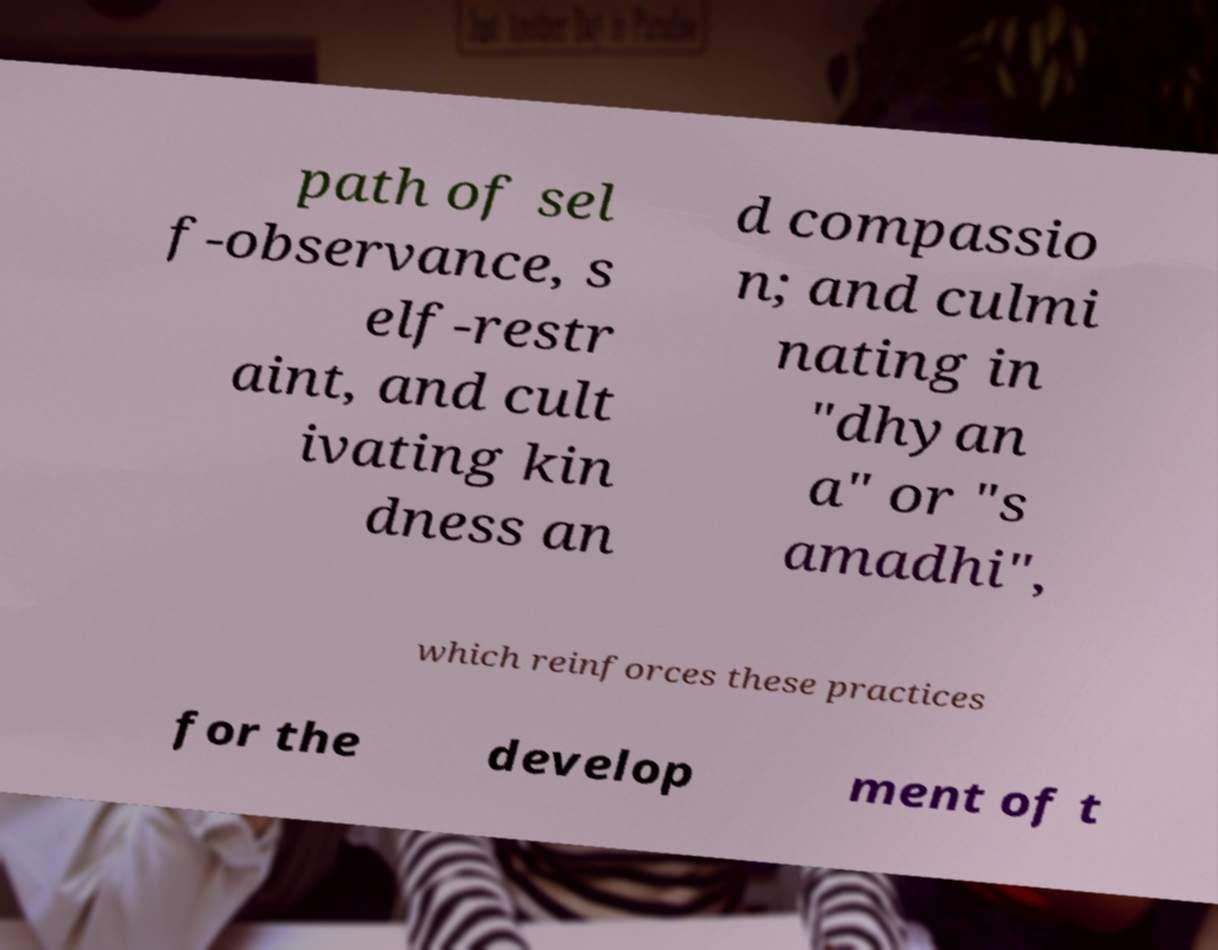There's text embedded in this image that I need extracted. Can you transcribe it verbatim? path of sel f-observance, s elf-restr aint, and cult ivating kin dness an d compassio n; and culmi nating in "dhyan a" or "s amadhi", which reinforces these practices for the develop ment of t 